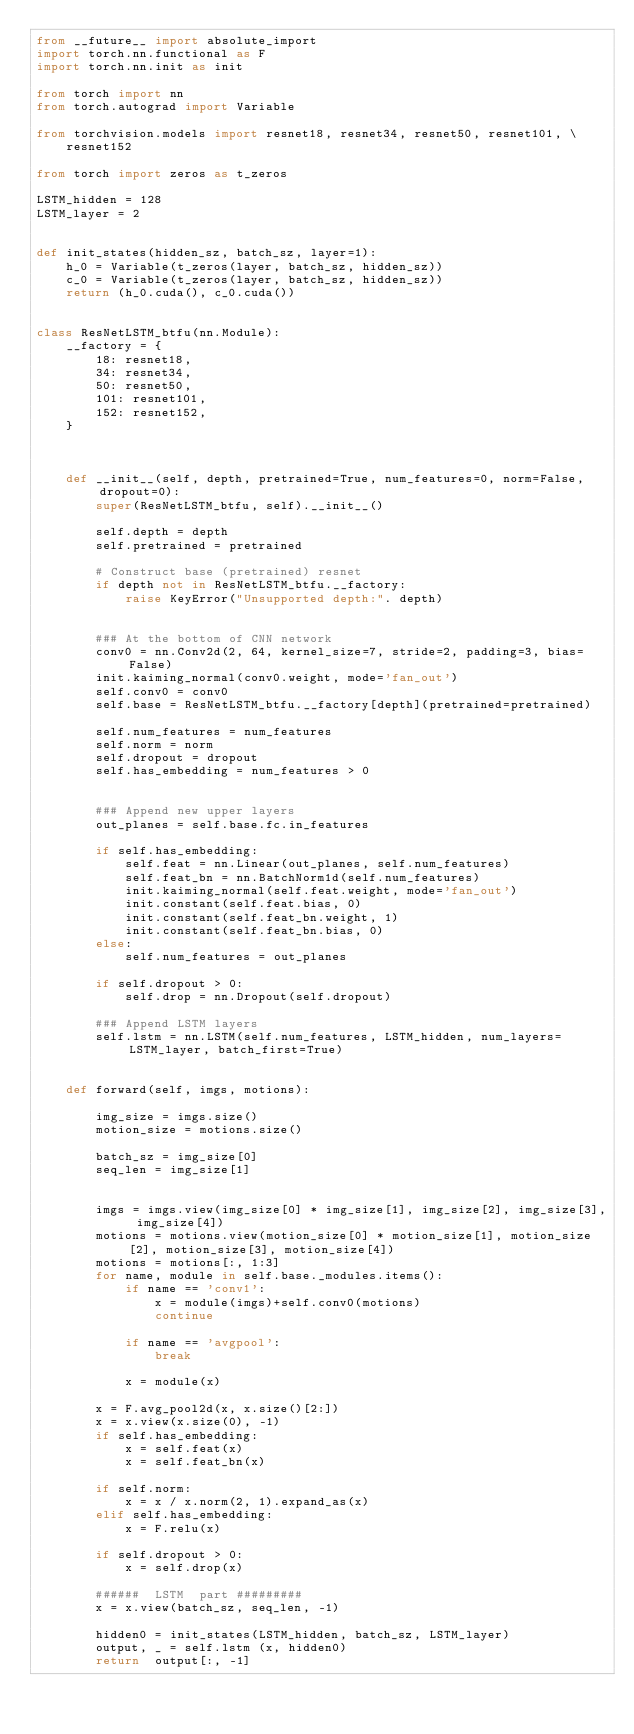Convert code to text. <code><loc_0><loc_0><loc_500><loc_500><_Python_>from __future__ import absolute_import
import torch.nn.functional as F
import torch.nn.init as init

from torch import nn
from torch.autograd import Variable

from torchvision.models import resnet18, resnet34, resnet50, resnet101, \
    resnet152

from torch import zeros as t_zeros

LSTM_hidden = 128
LSTM_layer = 2


def init_states(hidden_sz, batch_sz, layer=1):
    h_0 = Variable(t_zeros(layer, batch_sz, hidden_sz))
    c_0 = Variable(t_zeros(layer, batch_sz, hidden_sz))
    return (h_0.cuda(), c_0.cuda())


class ResNetLSTM_btfu(nn.Module):
    __factory = {
        18: resnet18,
        34: resnet34,
        50: resnet50,
        101: resnet101,
        152: resnet152,
    }



    def __init__(self, depth, pretrained=True, num_features=0, norm=False, dropout=0):
        super(ResNetLSTM_btfu, self).__init__()

        self.depth = depth
        self.pretrained = pretrained

        # Construct base (pretrained) resnet
        if depth not in ResNetLSTM_btfu.__factory:
            raise KeyError("Unsupported depth:". depth)


        ### At the bottom of CNN network
        conv0 = nn.Conv2d(2, 64, kernel_size=7, stride=2, padding=3, bias=False)
        init.kaiming_normal(conv0.weight, mode='fan_out')
        self.conv0 = conv0
        self.base = ResNetLSTM_btfu.__factory[depth](pretrained=pretrained)

        self.num_features = num_features
        self.norm = norm
        self.dropout = dropout
        self.has_embedding = num_features > 0


        ### Append new upper layers
        out_planes = self.base.fc.in_features

        if self.has_embedding:
            self.feat = nn.Linear(out_planes, self.num_features)
            self.feat_bn = nn.BatchNorm1d(self.num_features)
            init.kaiming_normal(self.feat.weight, mode='fan_out')
            init.constant(self.feat.bias, 0)
            init.constant(self.feat_bn.weight, 1)
            init.constant(self.feat_bn.bias, 0)
        else:
            self.num_features = out_planes

        if self.dropout > 0:
            self.drop = nn.Dropout(self.dropout)

        ### Append LSTM layers
        self.lstm = nn.LSTM(self.num_features, LSTM_hidden, num_layers=LSTM_layer, batch_first=True)


    def forward(self, imgs, motions):

        img_size = imgs.size()
        motion_size = motions.size()

        batch_sz = img_size[0]
        seq_len = img_size[1]


        imgs = imgs.view(img_size[0] * img_size[1], img_size[2], img_size[3], img_size[4])
        motions = motions.view(motion_size[0] * motion_size[1], motion_size[2], motion_size[3], motion_size[4])
        motions = motions[:, 1:3]
        for name, module in self.base._modules.items():
            if name == 'conv1':
                x = module(imgs)+self.conv0(motions)
                continue

            if name == 'avgpool':
                break

            x = module(x)

        x = F.avg_pool2d(x, x.size()[2:])
        x = x.view(x.size(0), -1)
        if self.has_embedding:
            x = self.feat(x)
            x = self.feat_bn(x)

        if self.norm:
            x = x / x.norm(2, 1).expand_as(x)
        elif self.has_embedding:
            x = F.relu(x)

        if self.dropout > 0:
            x = self.drop(x)

        ######  LSTM  part #########
        x = x.view(batch_sz, seq_len, -1)

        hidden0 = init_states(LSTM_hidden, batch_sz, LSTM_layer)
        output, _ = self.lstm (x, hidden0)
        return  output[:, -1]














</code> 